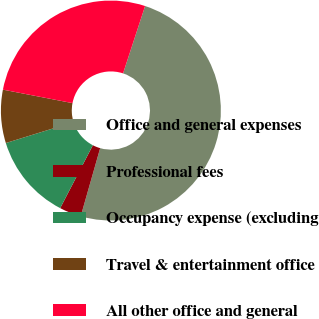Convert chart to OTSL. <chart><loc_0><loc_0><loc_500><loc_500><pie_chart><fcel>Office and general expenses<fcel>Professional fees<fcel>Occupancy expense (excluding<fcel>Travel & entertainment office<fcel>All other office and general<nl><fcel>49.39%<fcel>3.2%<fcel>12.6%<fcel>7.82%<fcel>26.99%<nl></chart> 